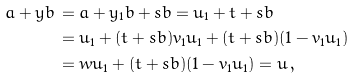Convert formula to latex. <formula><loc_0><loc_0><loc_500><loc_500>a + y b \, & = a + y _ { 1 } b + s b = u _ { 1 } + t + s b \\ & = u _ { 1 } + ( t + s b ) v _ { 1 } u _ { 1 } + ( t + s b ) ( 1 - v _ { 1 } u _ { 1 } ) \\ & = w u _ { 1 } + ( t + s b ) ( 1 - v _ { 1 } u _ { 1 } ) = u \, ,</formula> 